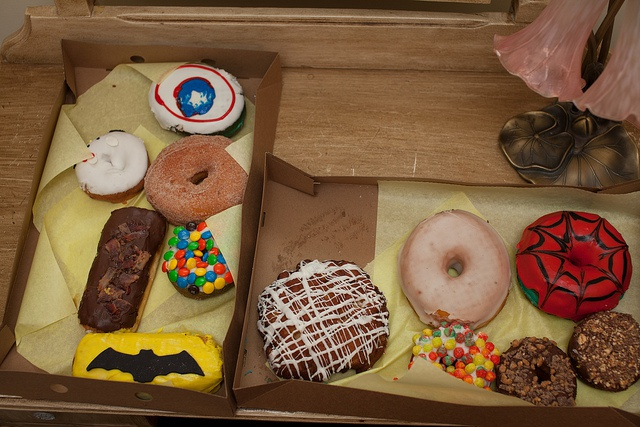Describe the objects in this image and their specific colors. I can see donut in gray, maroon, darkgray, and lightgray tones, donut in gray and tan tones, donut in gray, brown, maroon, black, and darkgreen tones, donut in gray, maroon, black, and brown tones, and donut in gray, gold, black, and olive tones in this image. 